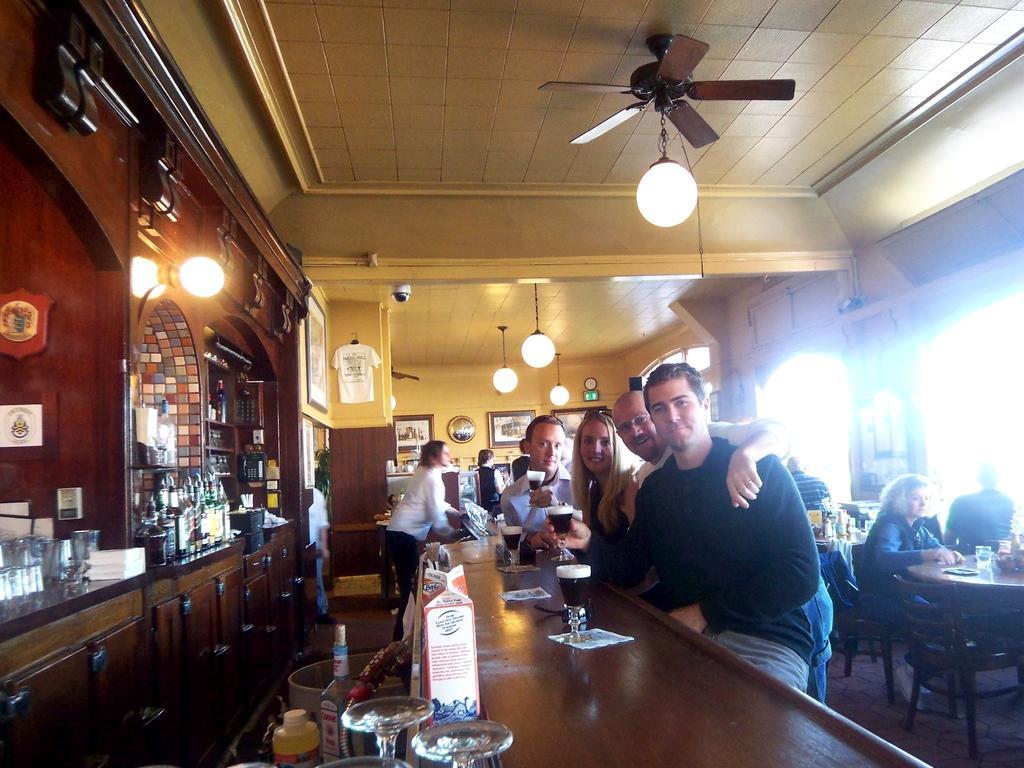Could you give a brief overview of what you see in this image? Here we can see a group of people are sitting on the chair, and in front here is the table and glasses and some objects on it, and at above here is the light, and here are the many bottles. 